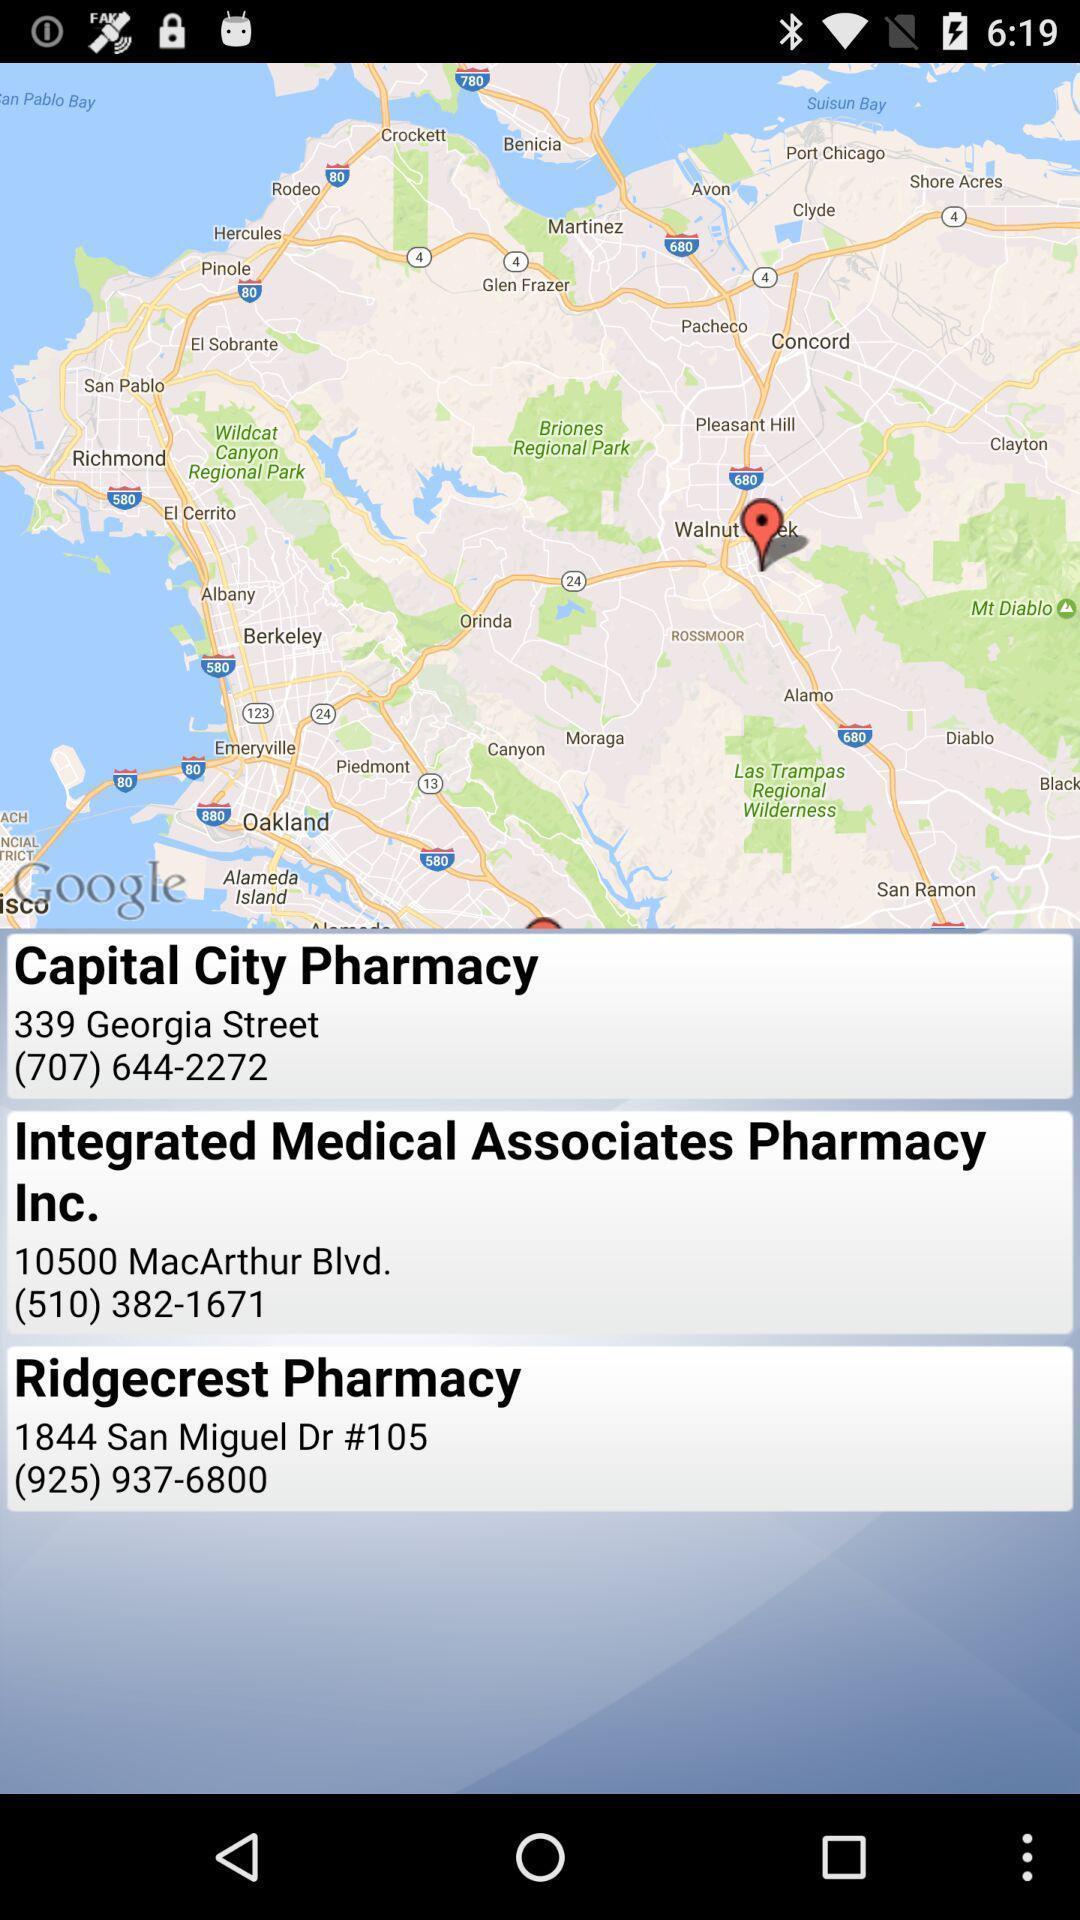What is the overall content of this screenshot? Page for connecting to pharmacy. 